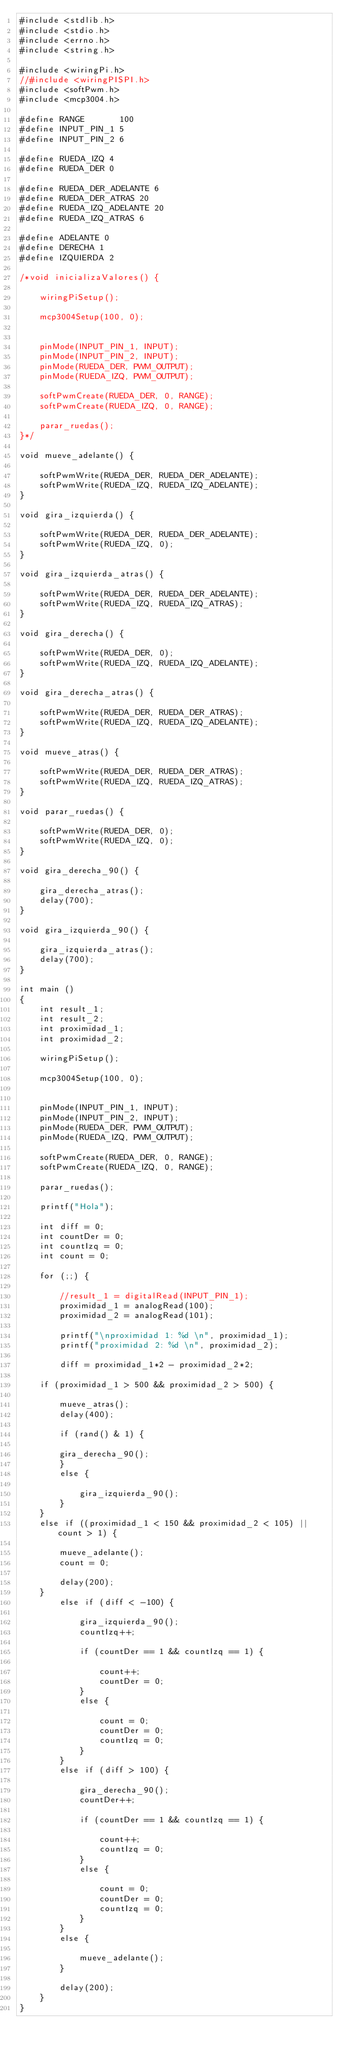Convert code to text. <code><loc_0><loc_0><loc_500><loc_500><_C_>#include <stdlib.h>
#include <stdio.h>
#include <errno.h>
#include <string.h>

#include <wiringPi.h>
//#include <wiringPISPI.h>
#include <softPwm.h>
#include <mcp3004.h>

#define RANGE		100
#define INPUT_PIN_1 5
#define INPUT_PIN_2 6

#define RUEDA_IZQ 4
#define RUEDA_DER 0

#define RUEDA_DER_ADELANTE 6
#define RUEDA_DER_ATRAS 20
#define RUEDA_IZQ_ADELANTE 20
#define RUEDA_IZQ_ATRAS 6

#define ADELANTE 0
#define DERECHA 1
#define IZQUIERDA 2

/*void inicializaValores() {

    wiringPiSetup();

    mcp3004Setup(100, 0);


    pinMode(INPUT_PIN_1, INPUT);
    pinMode(INPUT_PIN_2, INPUT);
    pinMode(RUEDA_DER, PWM_OUTPUT);
    pinMode(RUEDA_IZQ, PWM_OUTPUT);

    softPwmCreate(RUEDA_DER, 0, RANGE);
    softPwmCreate(RUEDA_IZQ, 0, RANGE);

    parar_ruedas();
}*/

void mueve_adelante() {

	softPwmWrite(RUEDA_DER, RUEDA_DER_ADELANTE);
	softPwmWrite(RUEDA_IZQ, RUEDA_IZQ_ADELANTE);
}

void gira_izquierda() {

	softPwmWrite(RUEDA_DER, RUEDA_DER_ADELANTE);
	softPwmWrite(RUEDA_IZQ, 0);
}

void gira_izquierda_atras() {

	softPwmWrite(RUEDA_DER, RUEDA_DER_ADELANTE);
	softPwmWrite(RUEDA_IZQ, RUEDA_IZQ_ATRAS);
}

void gira_derecha() {

	softPwmWrite(RUEDA_DER, 0);
	softPwmWrite(RUEDA_IZQ, RUEDA_IZQ_ADELANTE);
}

void gira_derecha_atras() {

	softPwmWrite(RUEDA_DER, RUEDA_DER_ATRAS);
	softPwmWrite(RUEDA_IZQ, RUEDA_IZQ_ADELANTE);
}

void mueve_atras() {

	softPwmWrite(RUEDA_DER, RUEDA_DER_ATRAS);
	softPwmWrite(RUEDA_IZQ, RUEDA_IZQ_ATRAS);
}

void parar_ruedas() {

	softPwmWrite(RUEDA_DER, 0);
	softPwmWrite(RUEDA_IZQ, 0);
}

void gira_derecha_90() {

	gira_derecha_atras();
	delay(700);
}

void gira_izquierda_90() {

	gira_izquierda_atras();
	delay(700);
}

int main ()
{
    int result_1;
    int result_2;
    int proximidad_1;
    int proximidad_2;

    wiringPiSetup();

    mcp3004Setup(100, 0);


    pinMode(INPUT_PIN_1, INPUT);
    pinMode(INPUT_PIN_2, INPUT);
    pinMode(RUEDA_DER, PWM_OUTPUT);
    pinMode(RUEDA_IZQ, PWM_OUTPUT);

    softPwmCreate(RUEDA_DER, 0, RANGE);
    softPwmCreate(RUEDA_IZQ, 0, RANGE);

    parar_ruedas();

    printf("Hola");

    int diff = 0;
    int countDer = 0;
    int countIzq = 0;
    int count = 0;

    for (;;) {

        //result_1 = digitalRead(INPUT_PIN_1);
        proximidad_1 = analogRead(100);
        proximidad_2 = analogRead(101);

        printf("\nproximidad 1: %d \n", proximidad_1);
        printf("proximidad 2: %d \n", proximidad_2);

        diff = proximidad_1*2 - proximidad_2*2;

	if (proximidad_1 > 500 && proximidad_2 > 500) {

	    mueve_atras();
	    delay(400);

	    if (rand() & 1) {

		gira_derecha_90();
	    }
	    else {
	    
	    	gira_izquierda_90();
	    }
	}
	else if ((proximidad_1 < 150 && proximidad_2 < 105) || count > 1) {
	
	    mueve_adelante();
	    count = 0;
	    
	    delay(200);
	}
        else if (diff < -100) {

            gira_izquierda_90();
            countIzq++;
            
            if (countDer == 1 && countIzq == 1) {
            
            	count++;
            	countDer = 0;
            }
            else {
            
            	count = 0;
            	countDer = 0;
            	countIzq = 0;
            }
        }
        else if (diff > 100) {

            gira_derecha_90();
            countDer++;
            
            if (countDer == 1 && countIzq == 1) {
            
            	count++;
            	countIzq = 0;
            }
            else {
            
            	count = 0;
            	countDer = 0;
            	countIzq = 0;
            }
        }
        else {

            mueve_adelante();
        }

        delay(200);
    }
}</code> 